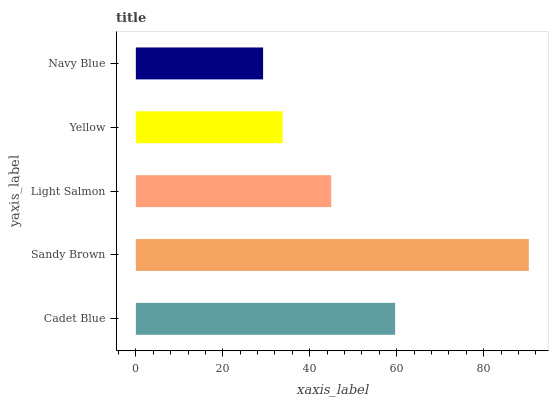Is Navy Blue the minimum?
Answer yes or no. Yes. Is Sandy Brown the maximum?
Answer yes or no. Yes. Is Light Salmon the minimum?
Answer yes or no. No. Is Light Salmon the maximum?
Answer yes or no. No. Is Sandy Brown greater than Light Salmon?
Answer yes or no. Yes. Is Light Salmon less than Sandy Brown?
Answer yes or no. Yes. Is Light Salmon greater than Sandy Brown?
Answer yes or no. No. Is Sandy Brown less than Light Salmon?
Answer yes or no. No. Is Light Salmon the high median?
Answer yes or no. Yes. Is Light Salmon the low median?
Answer yes or no. Yes. Is Cadet Blue the high median?
Answer yes or no. No. Is Cadet Blue the low median?
Answer yes or no. No. 